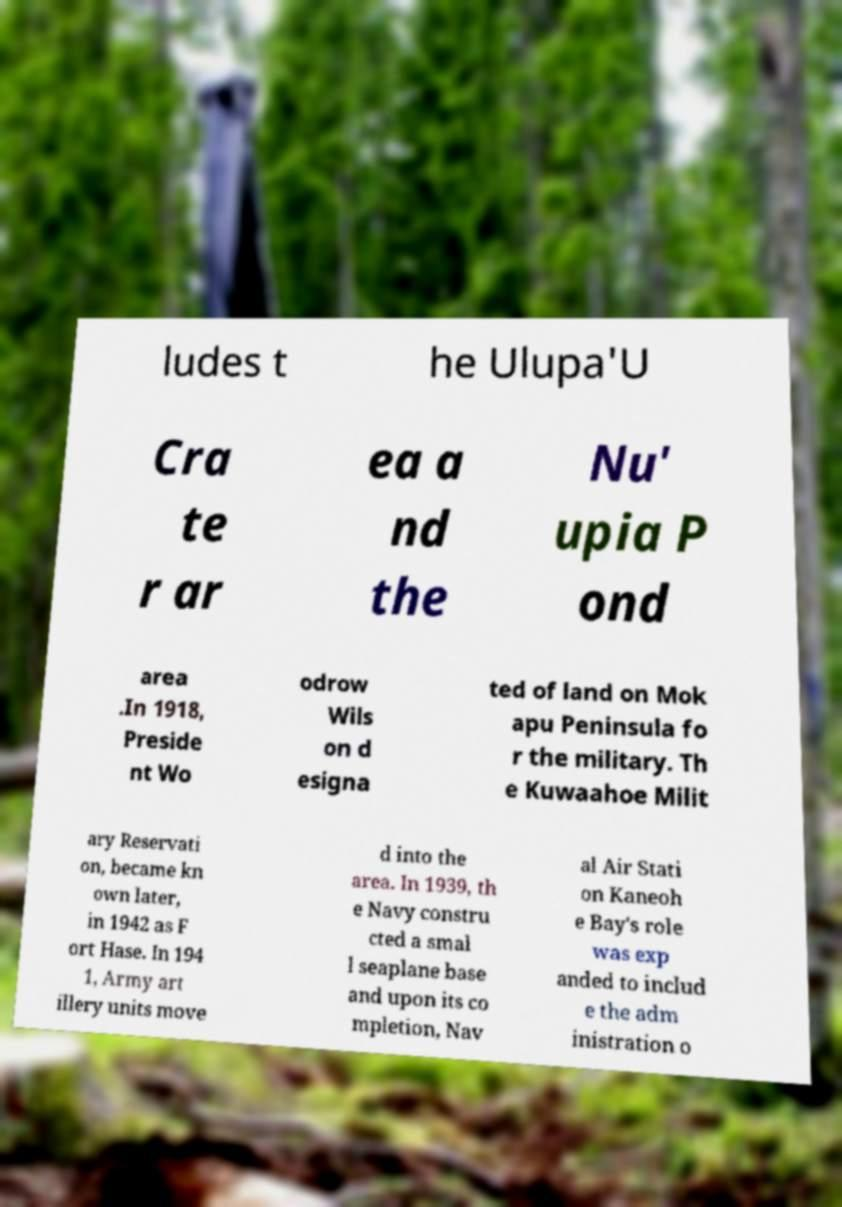Can you read and provide the text displayed in the image?This photo seems to have some interesting text. Can you extract and type it out for me? ludes t he Ulupa'U Cra te r ar ea a nd the Nu' upia P ond area .In 1918, Preside nt Wo odrow Wils on d esigna ted of land on Mok apu Peninsula fo r the military. Th e Kuwaahoe Milit ary Reservati on, became kn own later, in 1942 as F ort Hase. In 194 1, Army art illery units move d into the area. In 1939, th e Navy constru cted a smal l seaplane base and upon its co mpletion, Nav al Air Stati on Kaneoh e Bay's role was exp anded to includ e the adm inistration o 